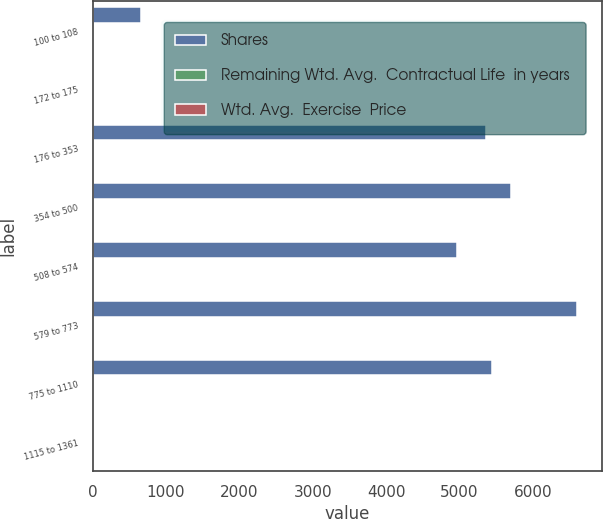<chart> <loc_0><loc_0><loc_500><loc_500><stacked_bar_chart><ecel><fcel>100 to 108<fcel>172 to 175<fcel>176 to 353<fcel>354 to 500<fcel>508 to 574<fcel>579 to 773<fcel>775 to 1110<fcel>1115 to 1361<nl><fcel>Shares<fcel>665<fcel>6.54<fcel>5354<fcel>5696<fcel>4959<fcel>6605<fcel>5440<fcel>6.54<nl><fcel>Remaining Wtd. Avg.  Contractual Life  in years<fcel>3.11<fcel>1.95<fcel>5.09<fcel>5.74<fcel>5.36<fcel>5.96<fcel>7.61<fcel>8.65<nl><fcel>Wtd. Avg.  Exercise  Price<fcel>1.05<fcel>1.75<fcel>3.34<fcel>4.04<fcel>5.72<fcel>7.12<fcel>9.77<fcel>12.9<nl></chart> 